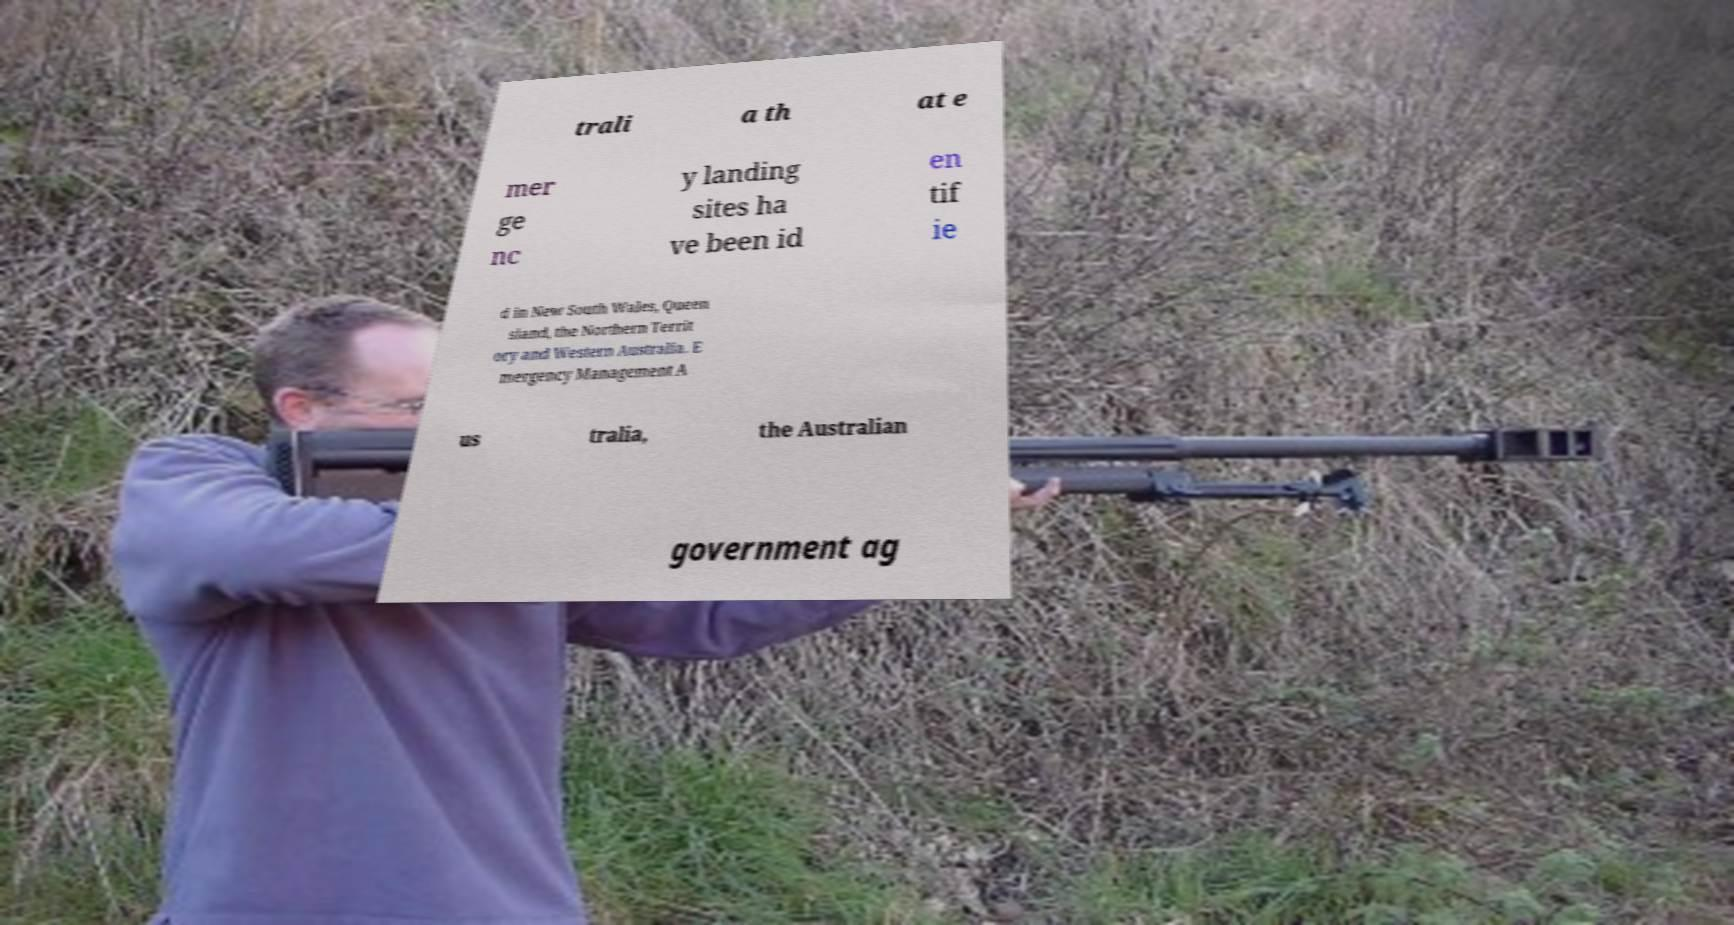Could you extract and type out the text from this image? trali a th at e mer ge nc y landing sites ha ve been id en tif ie d in New South Wales, Queen sland, the Northern Territ ory and Western Australia. E mergency Management A us tralia, the Australian government ag 